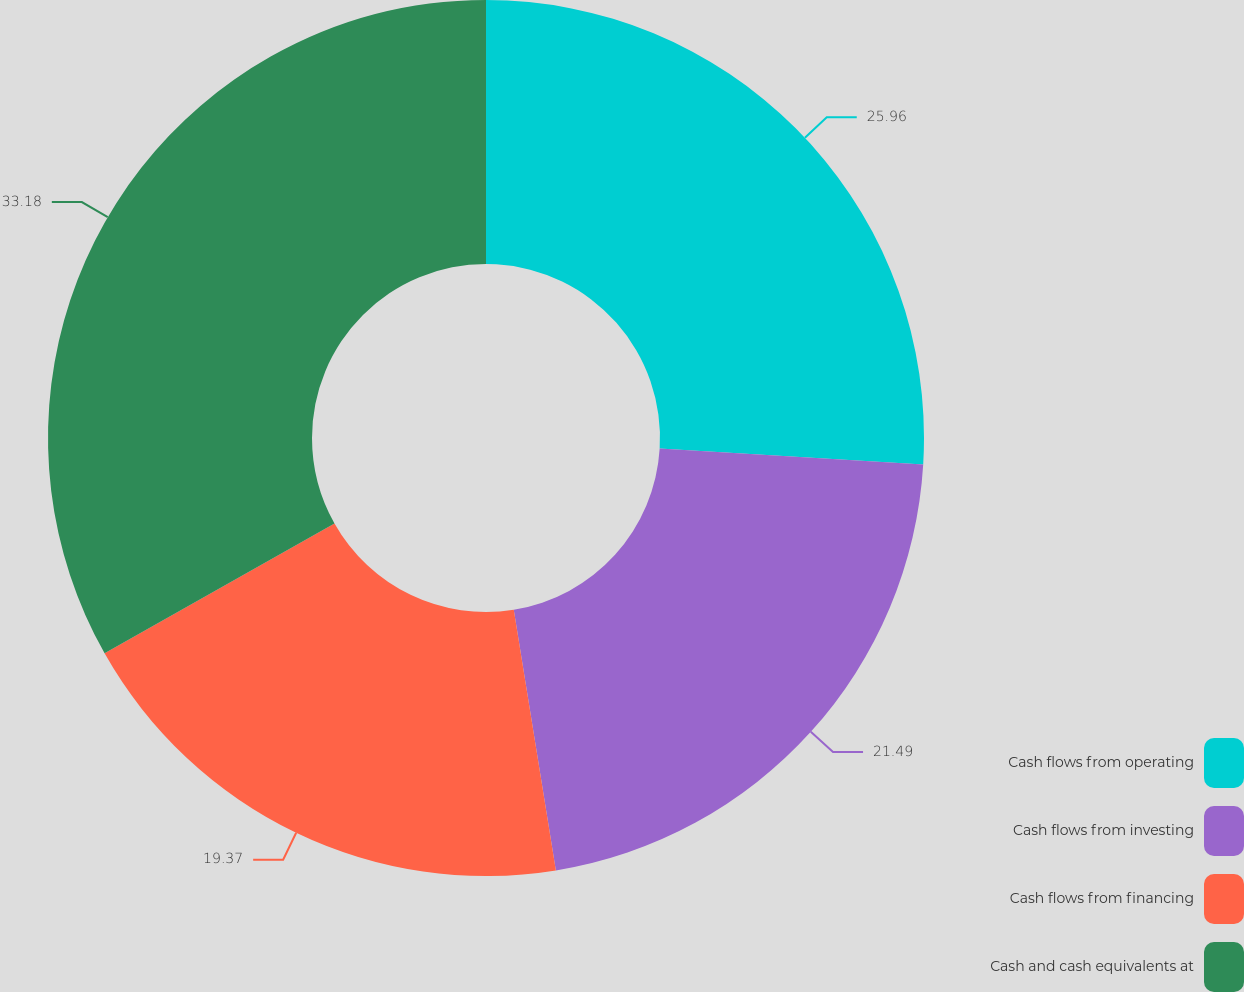Convert chart to OTSL. <chart><loc_0><loc_0><loc_500><loc_500><pie_chart><fcel>Cash flows from operating<fcel>Cash flows from investing<fcel>Cash flows from financing<fcel>Cash and cash equivalents at<nl><fcel>25.96%<fcel>21.49%<fcel>19.37%<fcel>33.18%<nl></chart> 